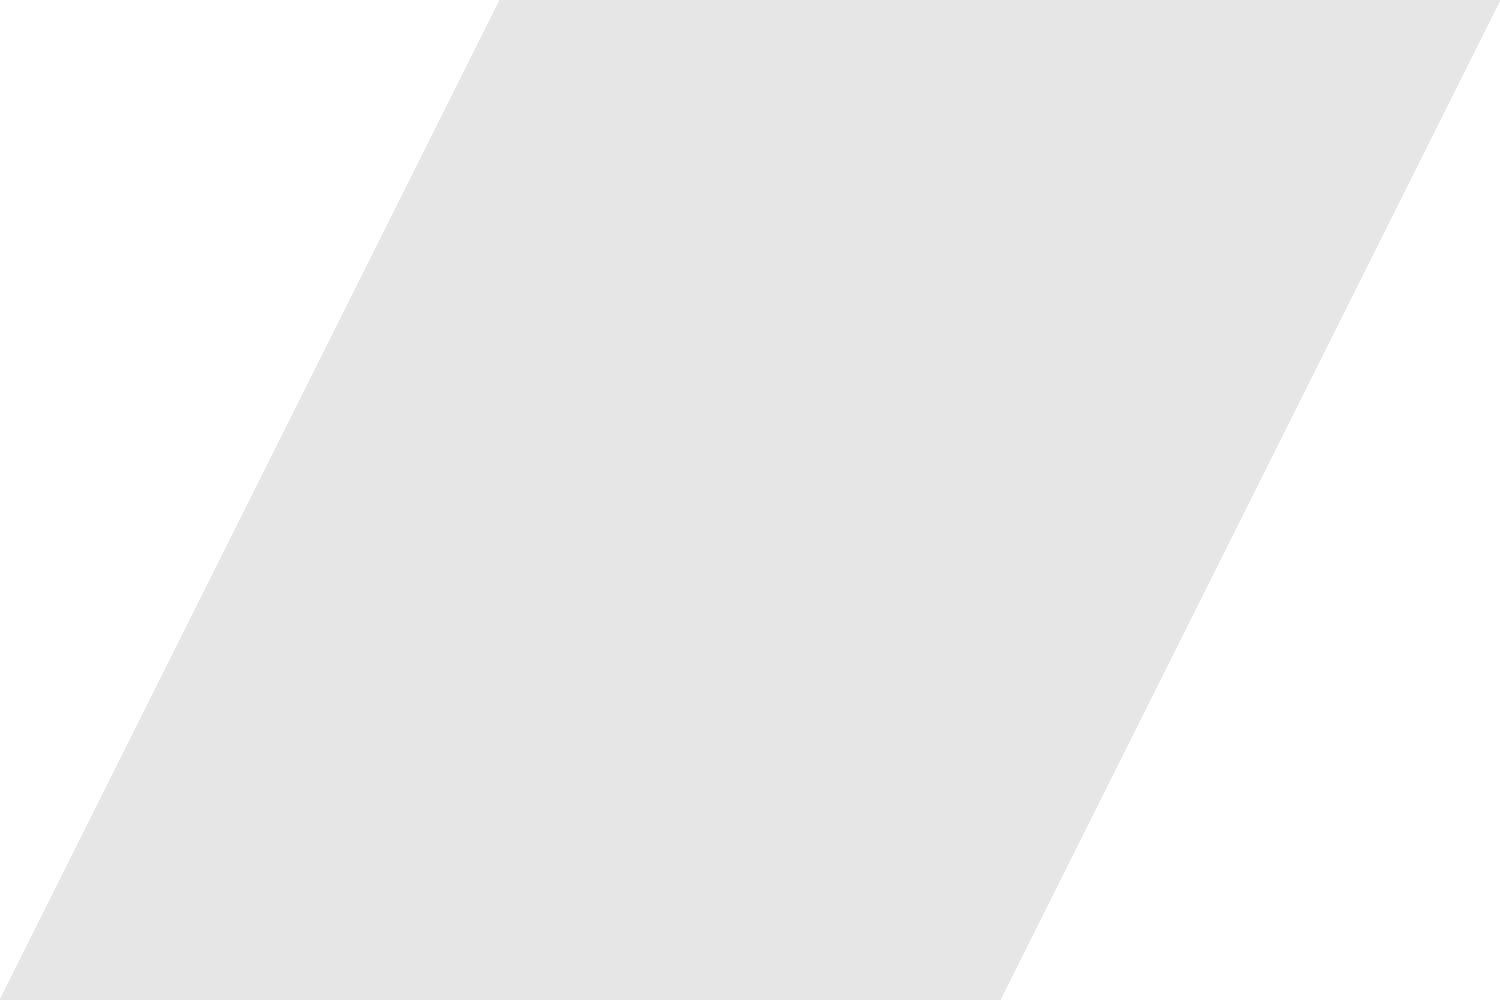Based on the labeled diagram of a volcano, what is the primary function of the conduit in the volcanic structure? To answer this question, let's analyze the structure of the volcano step-by-step:

1. The diagram shows a cross-section of a typical volcano.

2. At the bottom of the volcano, we can see a large, elliptical structure labeled "Magma chamber". This is where magma accumulates and is stored beneath the volcano.

3. Above the magma chamber, there's a narrow, vertical pathway labeled "Conduit". This structure connects the magma chamber to the surface of the volcano.

4. At the top of the volcano, we can see an opening labeled "Crater". This is where volcanic materials are typically ejected during an eruption.

5. The conduit serves as a passage for magma to move from the magma chamber to the surface during an eruption.

6. The diagram also shows an arrow indicating "Lava flow" coming out of the side of the volcano, which can occur when magma reaches the surface.

Given this structure, the primary function of the conduit is to provide a pathway for magma to move from the magma chamber to the surface during volcanic activity. It acts as a "pipe" through which molten rock and gases can travel upwards, eventually leading to eruptions at the crater or through fissures in the volcano's sides.
Answer: To provide a pathway for magma to move from the magma chamber to the surface 